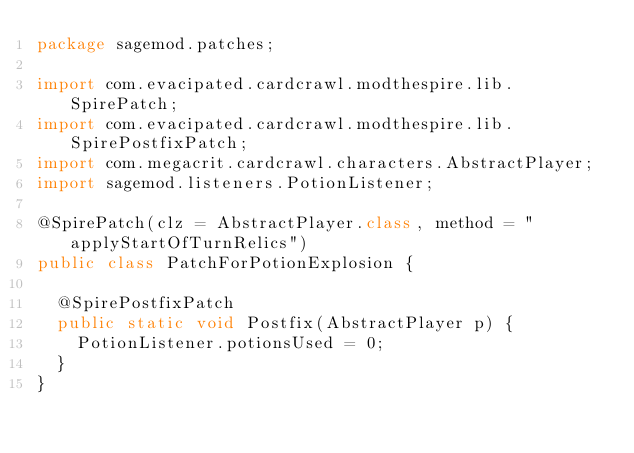Convert code to text. <code><loc_0><loc_0><loc_500><loc_500><_Java_>package sagemod.patches;

import com.evacipated.cardcrawl.modthespire.lib.SpirePatch;
import com.evacipated.cardcrawl.modthespire.lib.SpirePostfixPatch;
import com.megacrit.cardcrawl.characters.AbstractPlayer;
import sagemod.listeners.PotionListener;

@SpirePatch(clz = AbstractPlayer.class, method = "applyStartOfTurnRelics")
public class PatchForPotionExplosion {

	@SpirePostfixPatch
	public static void Postfix(AbstractPlayer p) {
		PotionListener.potionsUsed = 0;
	}
}
</code> 